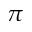Convert formula to latex. <formula><loc_0><loc_0><loc_500><loc_500>\pi</formula> 